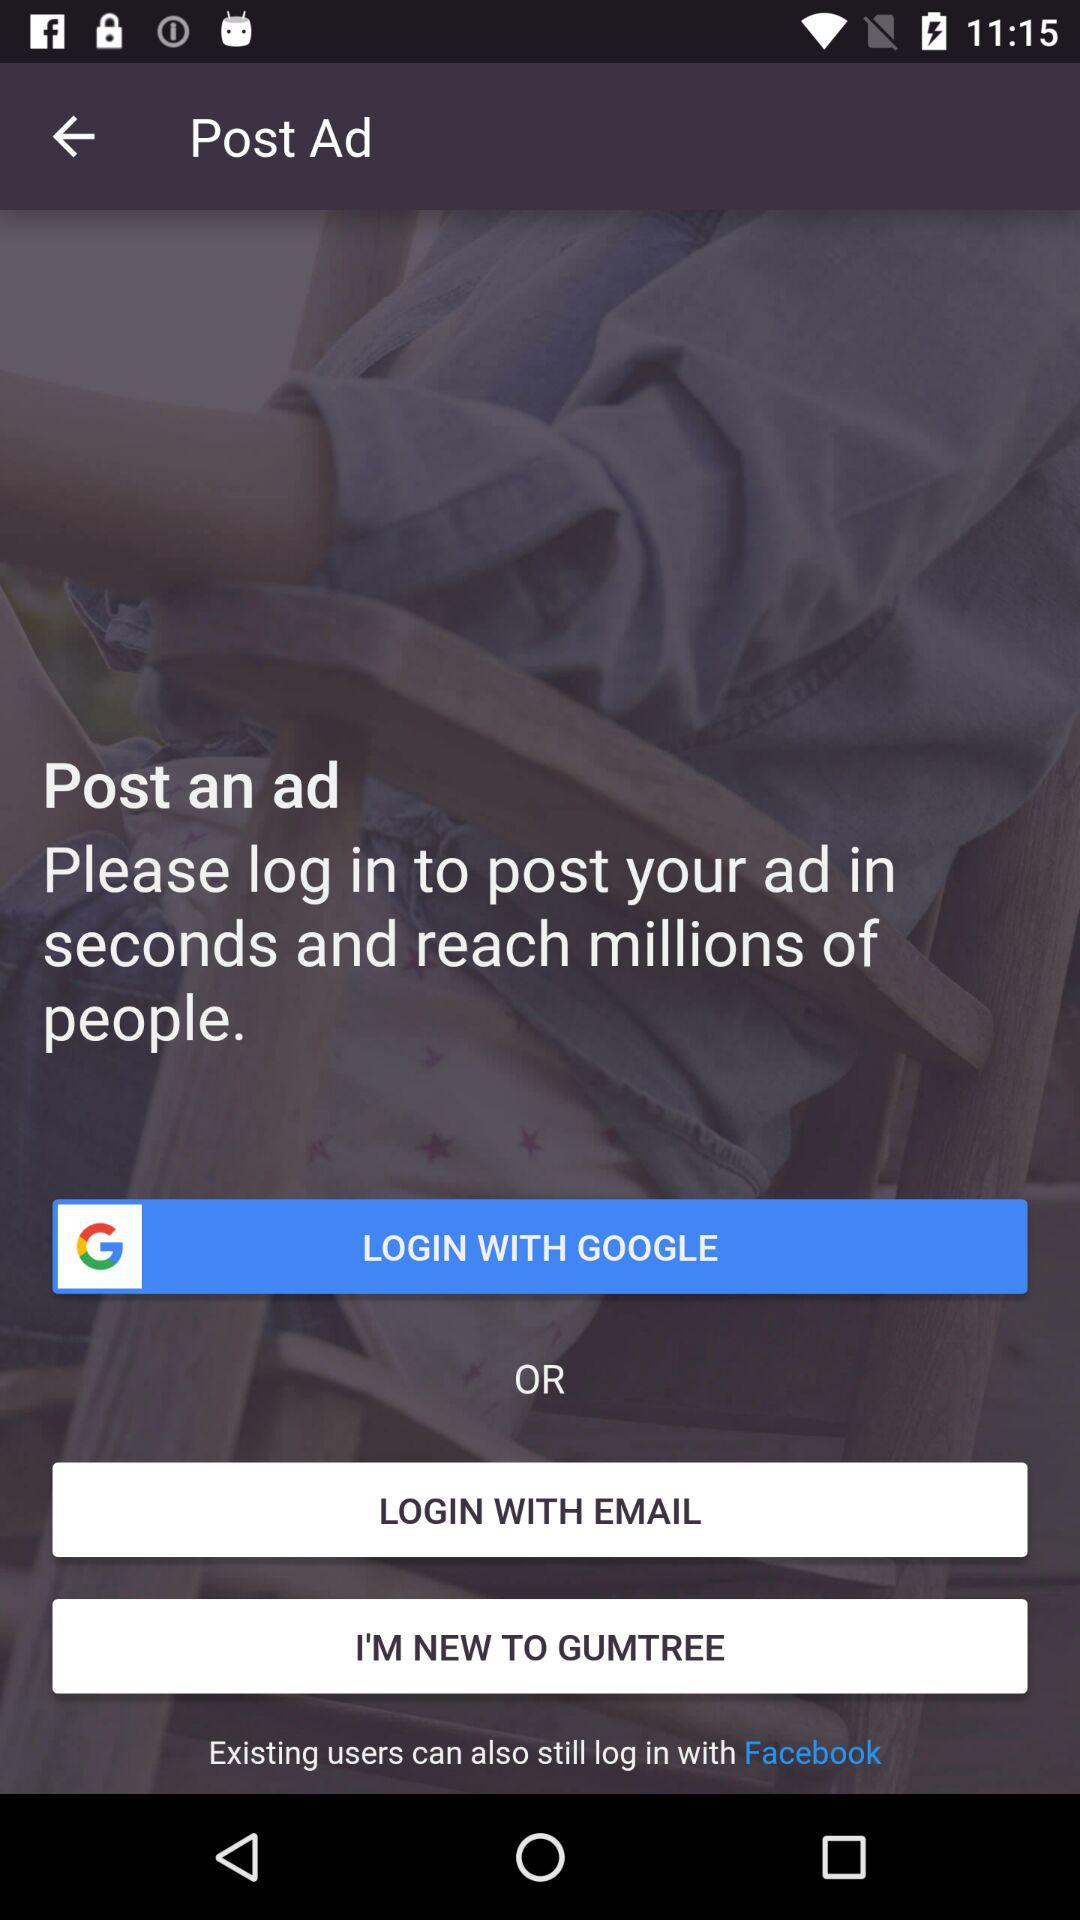What application can be used to log in? The application that can be used to log in is "GOOGLE". 